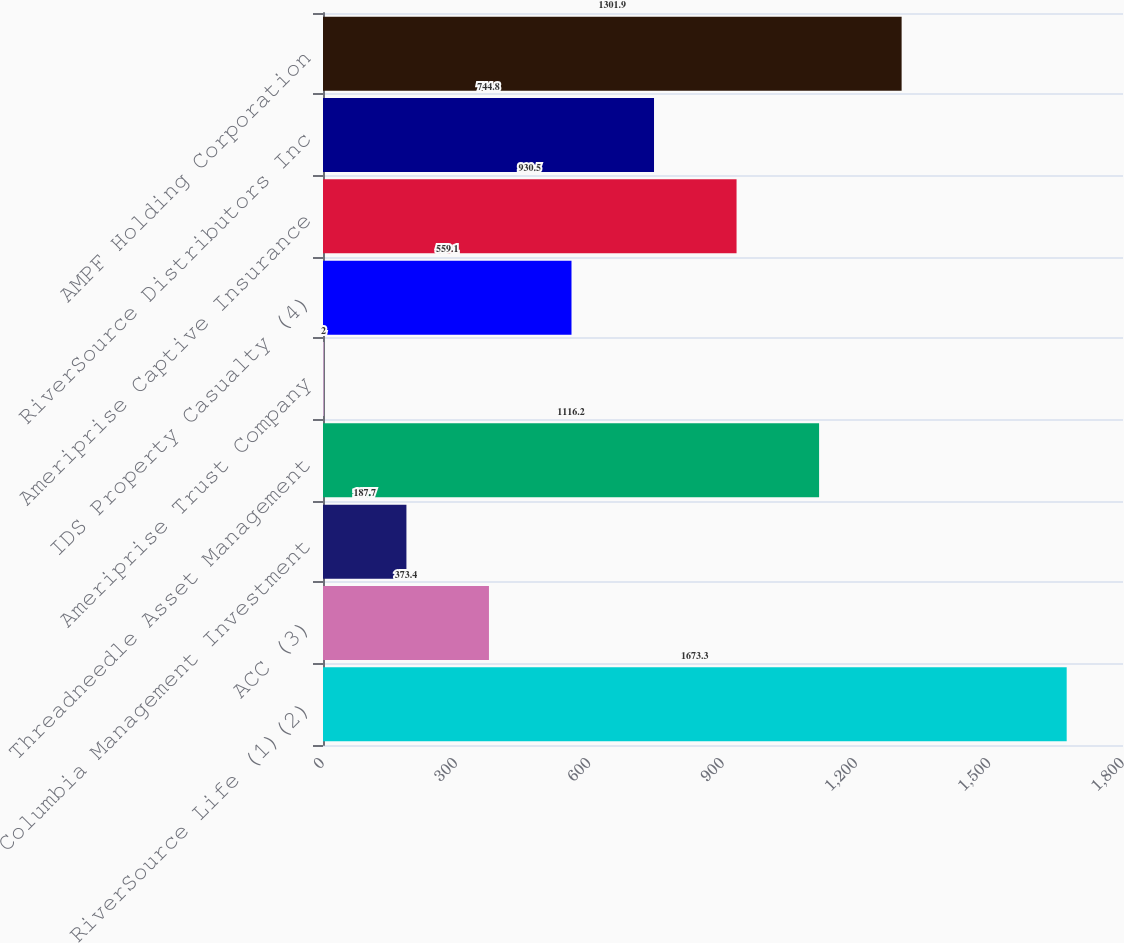Convert chart. <chart><loc_0><loc_0><loc_500><loc_500><bar_chart><fcel>RiverSource Life (1)(2)<fcel>ACC (3)<fcel>Columbia Management Investment<fcel>Threadneedle Asset Management<fcel>Ameriprise Trust Company<fcel>IDS Property Casualty (4)<fcel>Ameriprise Captive Insurance<fcel>RiverSource Distributors Inc<fcel>AMPF Holding Corporation<nl><fcel>1673.3<fcel>373.4<fcel>187.7<fcel>1116.2<fcel>2<fcel>559.1<fcel>930.5<fcel>744.8<fcel>1301.9<nl></chart> 